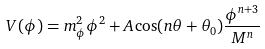Convert formula to latex. <formula><loc_0><loc_0><loc_500><loc_500>V ( \phi ) = m _ { \phi } ^ { 2 } \phi ^ { 2 } + A \cos ( n \theta + \theta _ { 0 } ) \frac { \phi ^ { n + 3 } } { M ^ { n } }</formula> 